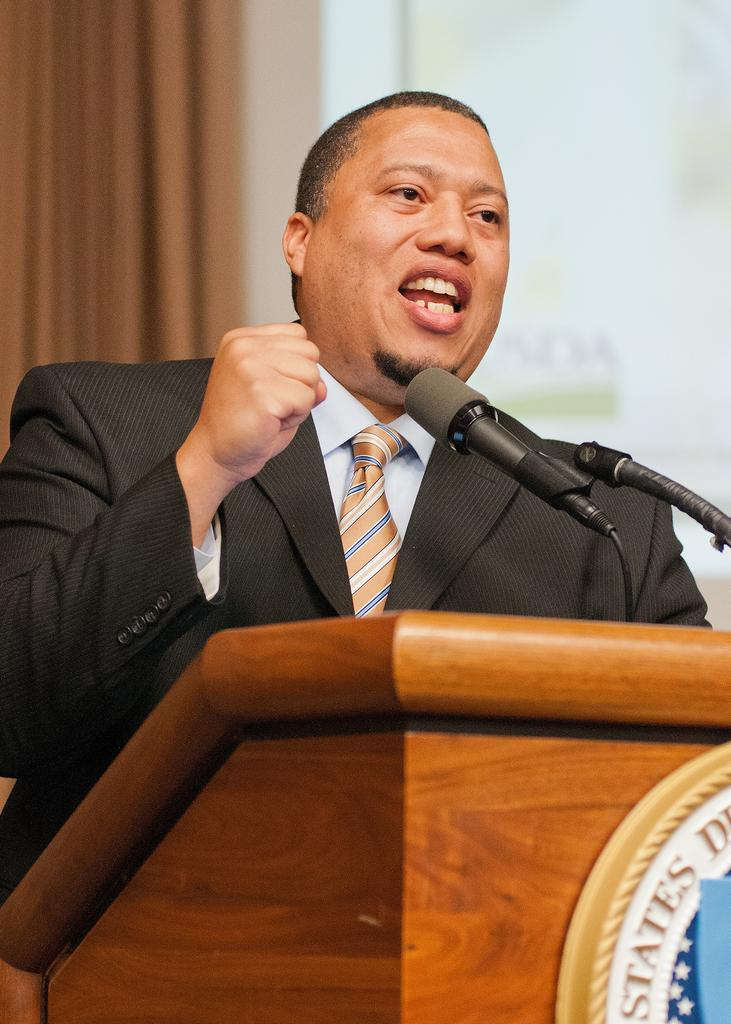Who is the person in the image? There is a man in the image. What is the man wearing? The man is wearing a blazer and a tie. What is the man doing in the image? The man is standing at a podium and talking on a microphone. What can be seen in the background of the image? There is a curtain in the background of the image. What type of net can be seen in the image? There is no net present in the image. How many cents are visible in the image? There are no cents visible in the image. 